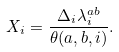<formula> <loc_0><loc_0><loc_500><loc_500>X _ { i } = \frac { \Delta _ { i } \lambda ^ { a b } _ { i } } { \theta ( a , b , i ) } .</formula> 